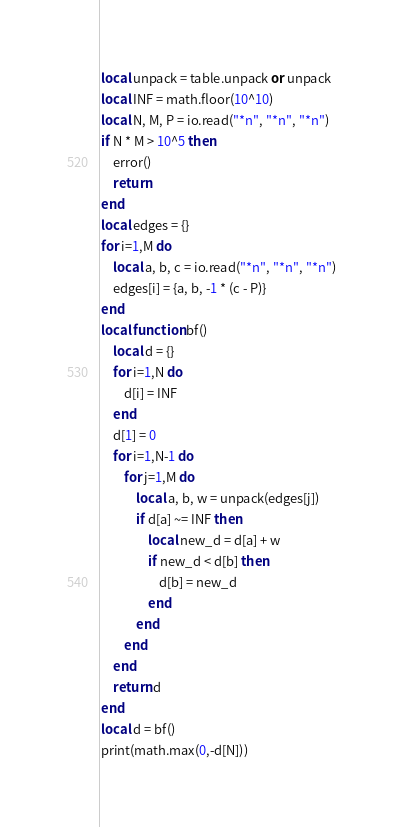Convert code to text. <code><loc_0><loc_0><loc_500><loc_500><_Lua_>local unpack = table.unpack or unpack
local INF = math.floor(10^10)
local N, M, P = io.read("*n", "*n", "*n")
if N * M > 10^5 then
    error()
    return
end
local edges = {}
for i=1,M do
    local a, b, c = io.read("*n", "*n", "*n")
    edges[i] = {a, b, -1 * (c - P)}
end
local function bf()
    local d = {}
    for i=1,N do
        d[i] = INF
    end
    d[1] = 0
    for i=1,N-1 do
        for j=1,M do
            local a, b, w = unpack(edges[j])
            if d[a] ~= INF then
                local new_d = d[a] + w
                if new_d < d[b] then
                    d[b] = new_d
                end
            end
        end
    end
    return d
end
local d = bf()
print(math.max(0,-d[N]))
</code> 